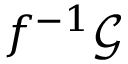<formula> <loc_0><loc_0><loc_500><loc_500>f ^ { - 1 } { \mathcal { G } }</formula> 